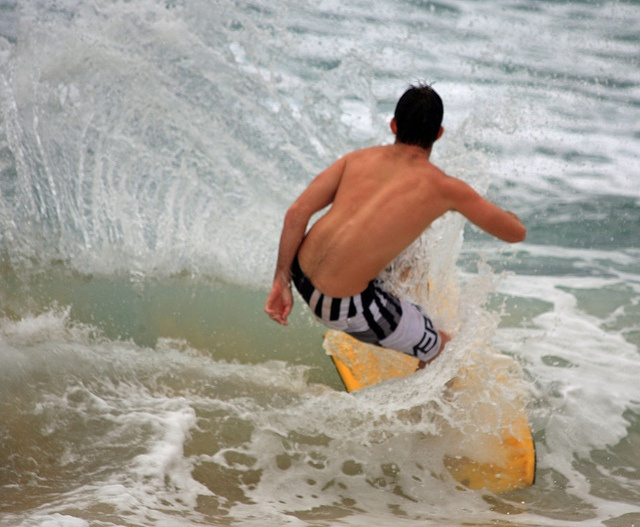Describe the objects in this image and their specific colors. I can see people in darkgray, brown, black, and salmon tones and surfboard in darkgray and tan tones in this image. 